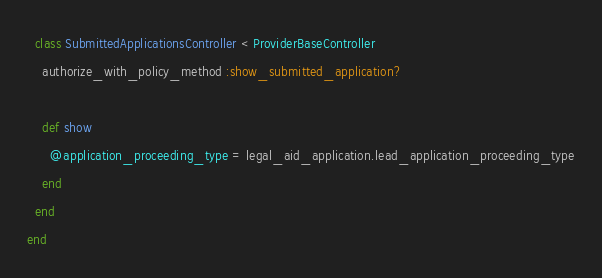Convert code to text. <code><loc_0><loc_0><loc_500><loc_500><_Ruby_>  class SubmittedApplicationsController < ProviderBaseController
    authorize_with_policy_method :show_submitted_application?

    def show
      @application_proceeding_type = legal_aid_application.lead_application_proceeding_type
    end
  end
end
</code> 